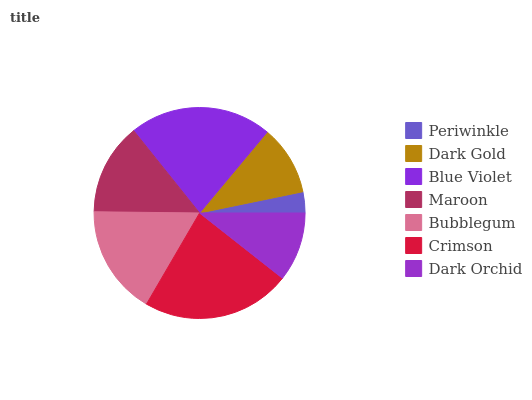Is Periwinkle the minimum?
Answer yes or no. Yes. Is Crimson the maximum?
Answer yes or no. Yes. Is Dark Gold the minimum?
Answer yes or no. No. Is Dark Gold the maximum?
Answer yes or no. No. Is Dark Gold greater than Periwinkle?
Answer yes or no. Yes. Is Periwinkle less than Dark Gold?
Answer yes or no. Yes. Is Periwinkle greater than Dark Gold?
Answer yes or no. No. Is Dark Gold less than Periwinkle?
Answer yes or no. No. Is Maroon the high median?
Answer yes or no. Yes. Is Maroon the low median?
Answer yes or no. Yes. Is Dark Orchid the high median?
Answer yes or no. No. Is Periwinkle the low median?
Answer yes or no. No. 